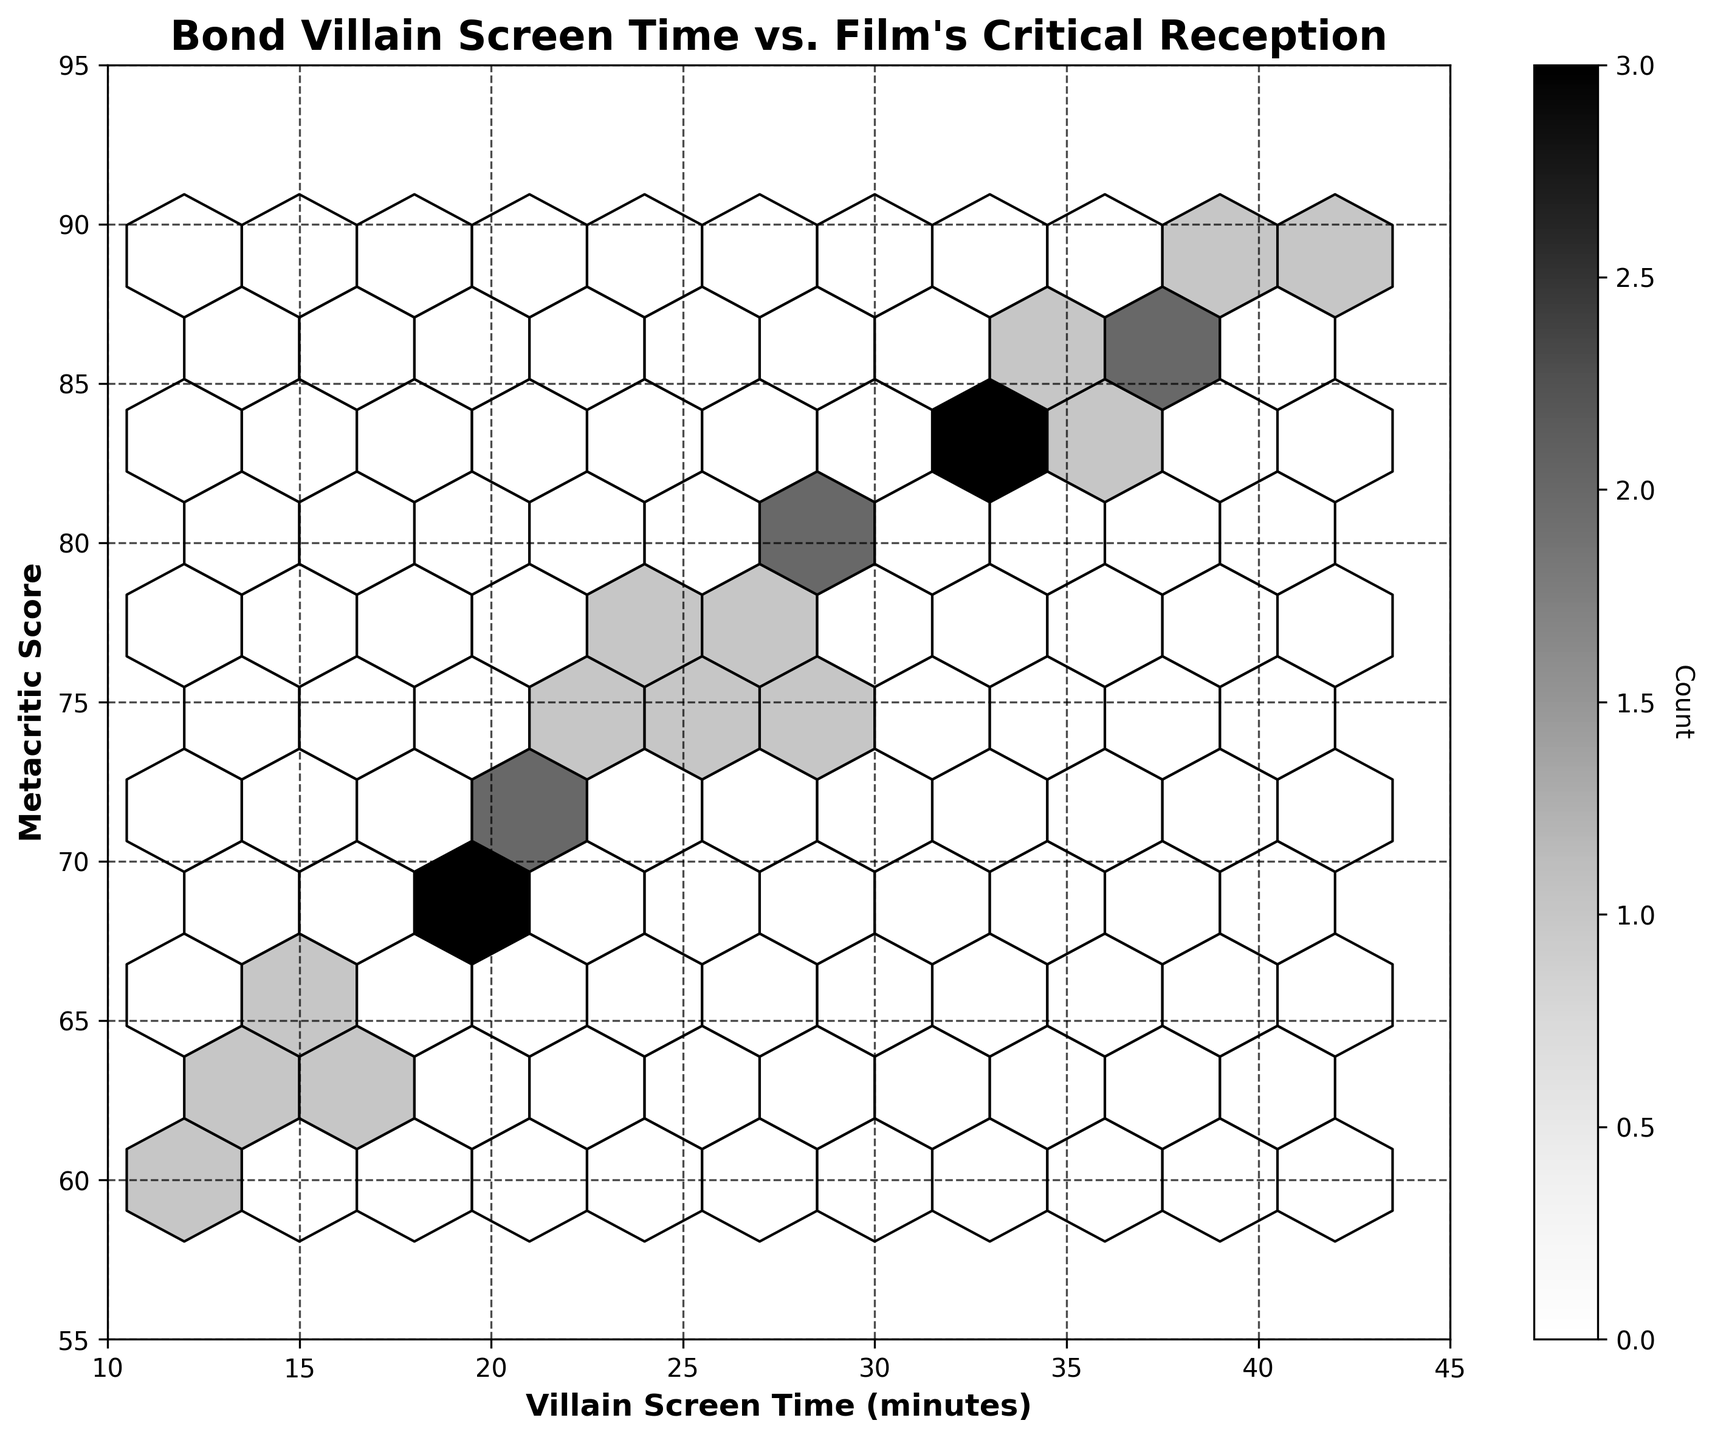What's the title of the hexbin plot? The title of this plot is typically displayed at the top center. By looking at the specified area, you can find "Bond Villain Screen Time vs. Film's Critical Reception" written there.
Answer: Bond Villain Screen Time vs. Film's Critical Reception How many hexagonal bins are used in the plot? The number of hexagonal bins can be inferred from the gridsize parameter set to 10 in the code. This means the plot is divided into a grid with a certain number of bins. By counting them in the image, you can observe 10 across each axis.
Answer: 10 What's the range of the 'Villain Screen Time (minutes)' axis? Look at the bottom horizontal axis of the plot. You will see the range starts at 10 and goes up to 45 based on the axis labels.
Answer: 10 to 45 What does the color of the hexagons indicate? In a hexbin plot, the color intensity usually represents the density or count of data points falling in that bin. The plot's colorbar indicates this as "Count".
Answer: Count How does the 'Metacritic Score' generally change with increasing 'Villain Screen Time'? By visually inspecting the plot, you can see that as the 'Villain Screen Time' increases from left to right, 'Metacritic Score' tends also to increase, showing a positive relationship.
Answer: Increases What is the primary color palette used for the hexagons? The chosen color map for the hexagons is 'Greys', so the primary palette involves shades of grey.
Answer: Shades of grey What is the count of the most frequently occurring hexagon? To find the most frequently occurring hexagon, inspect the colorbar and identify the darkest hexagon's count. The darkest shade corresponds to the highest count, which is around 3.
Answer: 3 Which has a higher score on average: films with villain screen time below 20 minutes or those with screen time above 30 minutes? By examining the plot:
- For screen time below 20 minutes (x<20), the 'Metacritic Score' averages around the lower 60-70.
- For screen time above 30 minutes (x>30), scores average around 80-90.
Hence, films with villain screen time above 30 minutes have a higher average score.
Answer: Above 30 minutes What is the exact label of the color bar and its orientation? The label on the color bar, which shows the significance of the color shades, is 'Count'. Its orientation is vertical, confirmed by the text rotating 270 degrees to align with the bar.
Answer: Count, vertical 